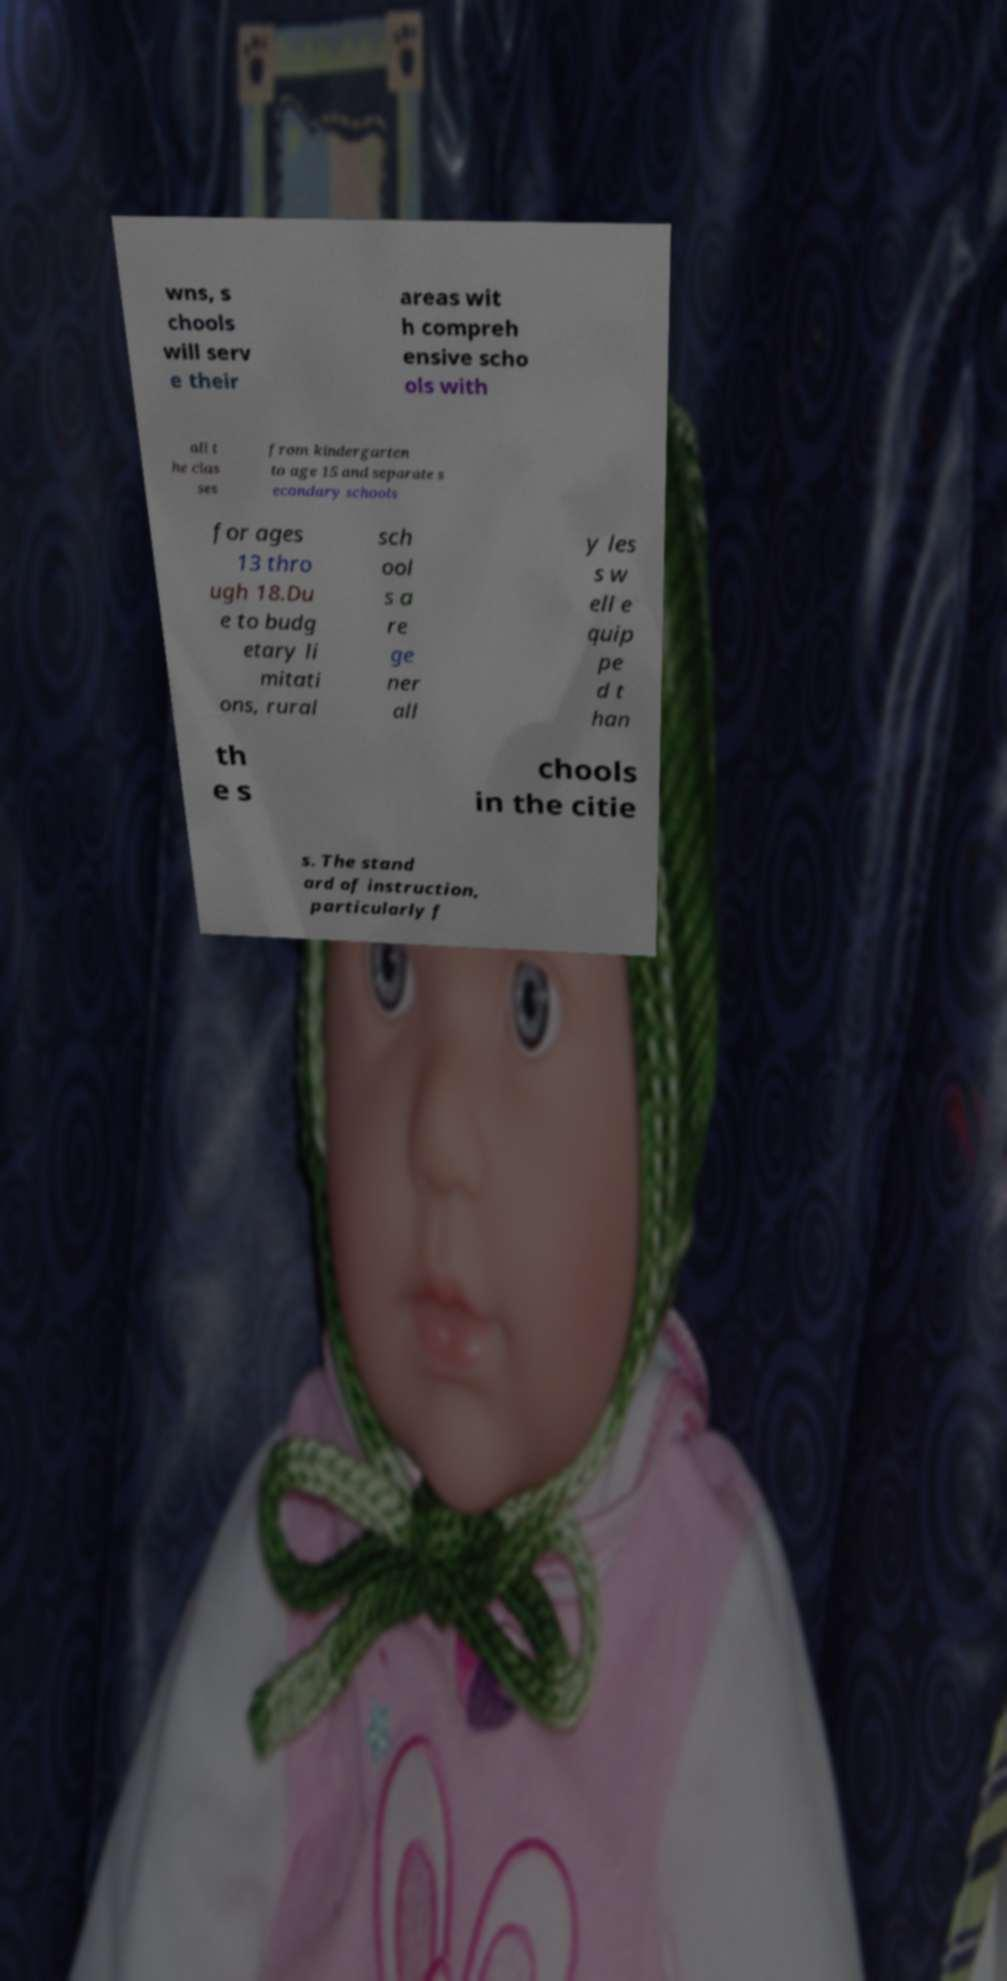I need the written content from this picture converted into text. Can you do that? wns, s chools will serv e their areas wit h compreh ensive scho ols with all t he clas ses from kindergarten to age 15 and separate s econdary schools for ages 13 thro ugh 18.Du e to budg etary li mitati ons, rural sch ool s a re ge ner all y les s w ell e quip pe d t han th e s chools in the citie s. The stand ard of instruction, particularly f 